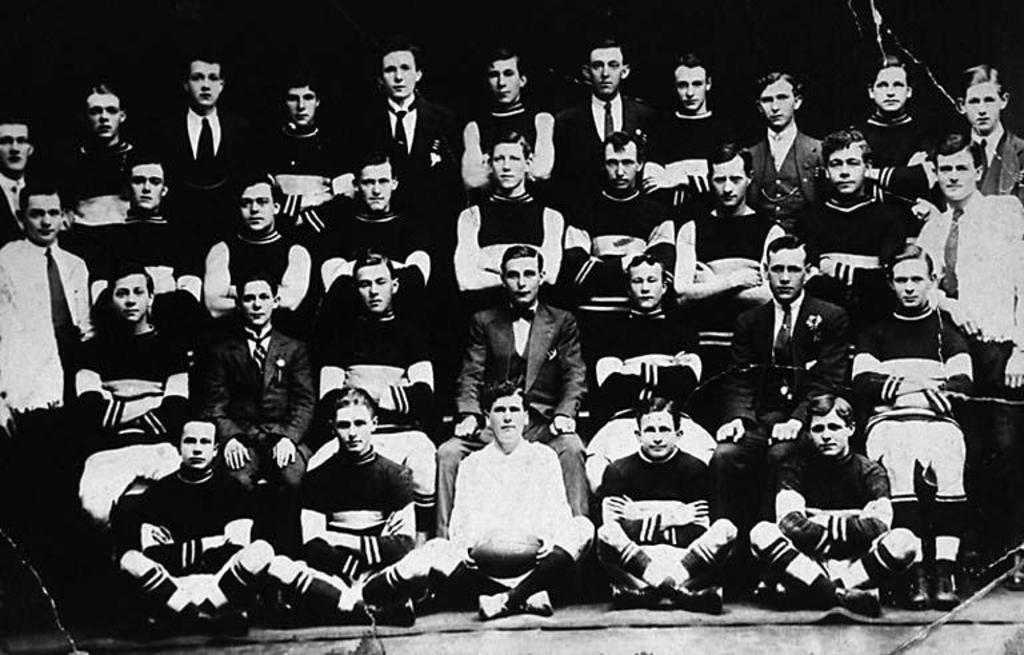What is the color scheme of the image? The image is black and white. What are the people in the image doing? Some people are standing, while others are sitting in the image. Where are some of the people sitting in the image? Some people are sitting on a mat in the image. What type of insect can be seen making a statement in the image? There are no insects present in the image, and therefore no insects can be seen making a statement. 